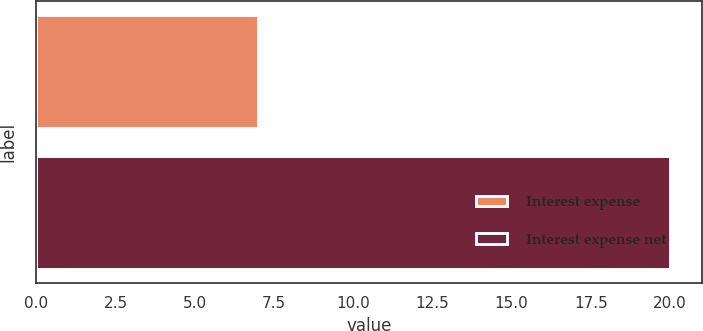Convert chart. <chart><loc_0><loc_0><loc_500><loc_500><bar_chart><fcel>Interest expense<fcel>Interest expense net<nl><fcel>7<fcel>20<nl></chart> 